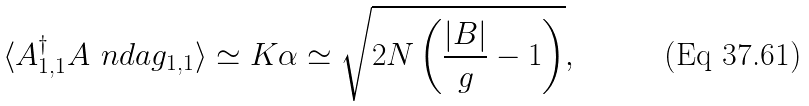<formula> <loc_0><loc_0><loc_500><loc_500>\langle A _ { 1 , 1 } ^ { \dag } A ^ { \ } n d a g _ { 1 , 1 } \rangle \simeq K \alpha \simeq \sqrt { 2 N \left ( \frac { | B | } g - 1 \right ) } ,</formula> 